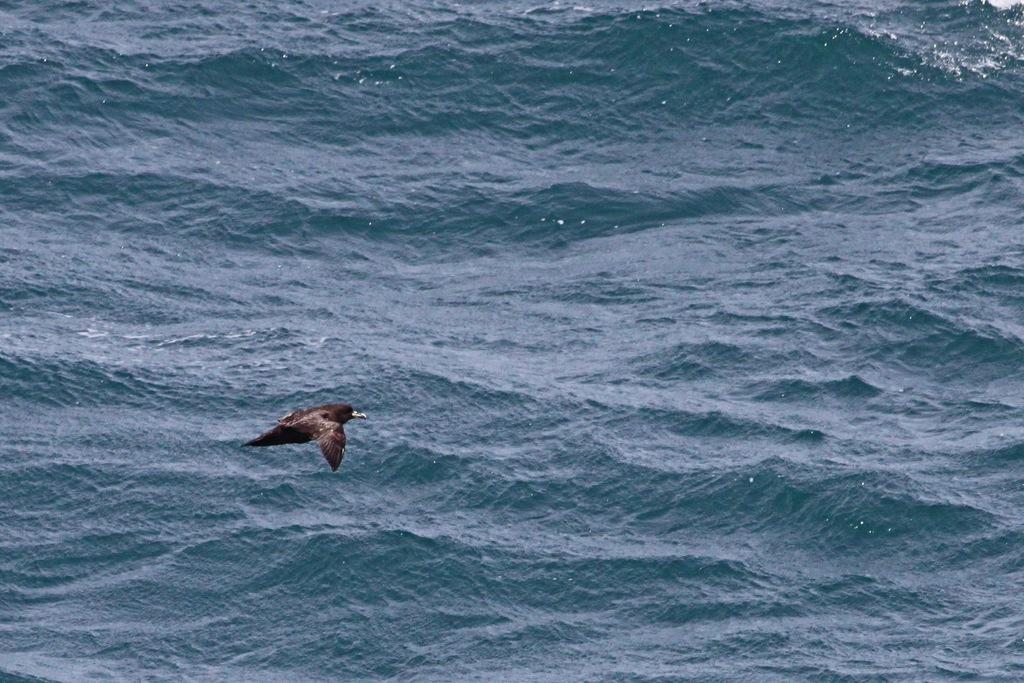What type of animal is in the image? There is a bird in the image. What color is the bird? The bird is brown in color. What can be seen in the background of the image? There is water visible in the background of the image. What is the bird's creator doing in the image? There is no information about a creator in the image, as it only features a brown bird and water in the background. 